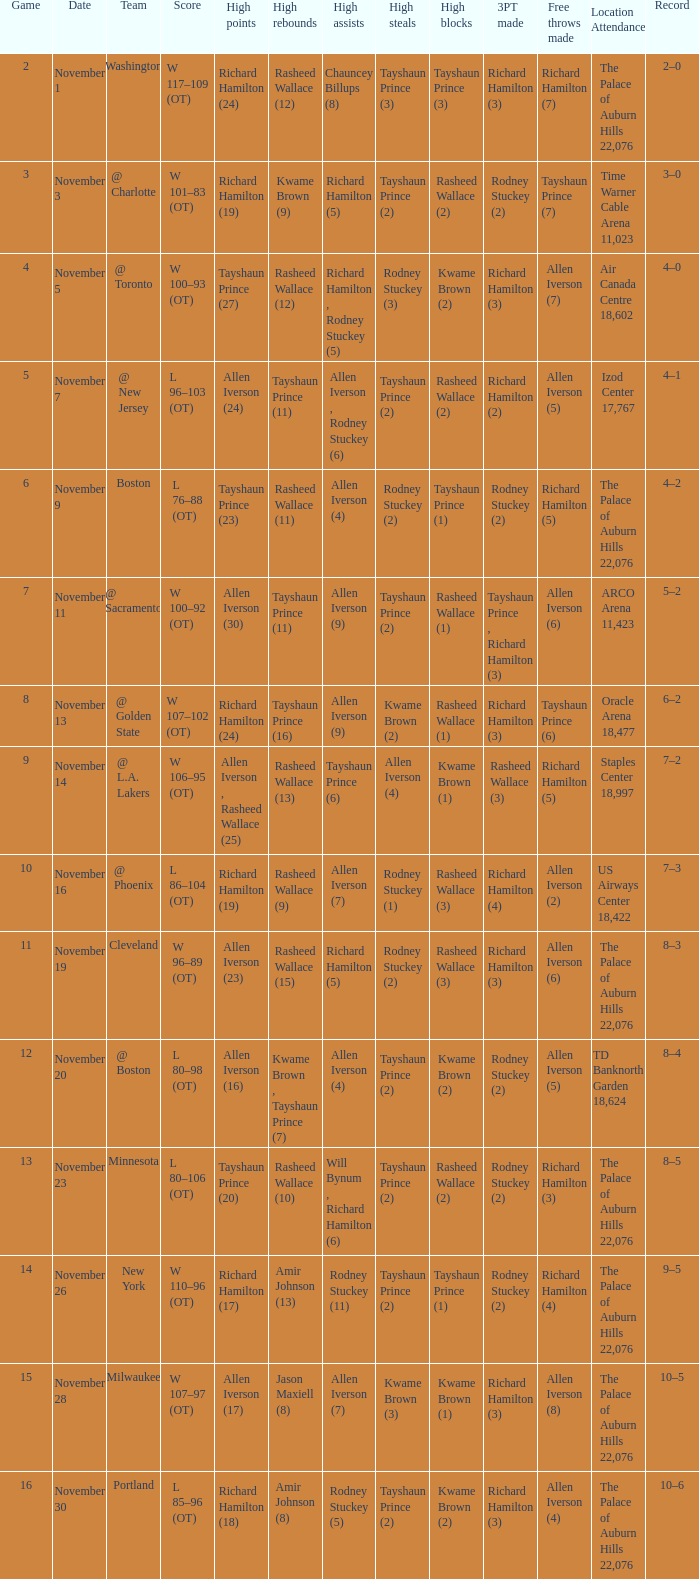What is the average Game, when Team is "Milwaukee"? 15.0. 